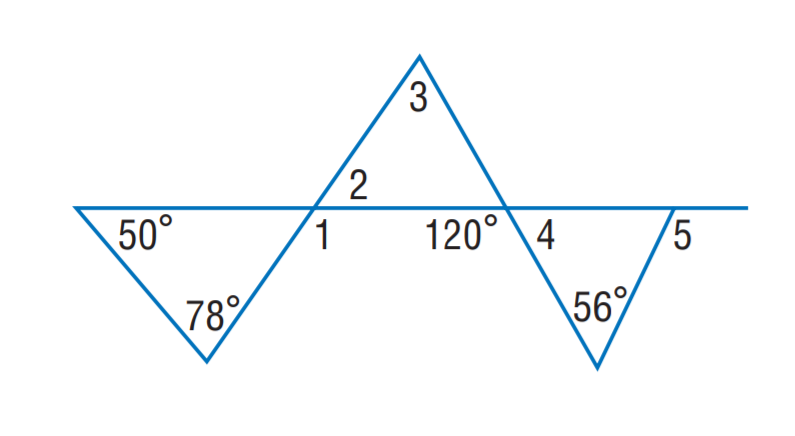Answer the mathemtical geometry problem and directly provide the correct option letter.
Question: Find m \angle 3.
Choices: A: 56 B: 56 C: 68 D: 78 C 